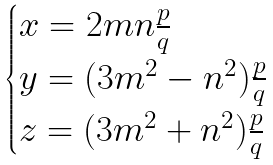<formula> <loc_0><loc_0><loc_500><loc_500>\begin{cases} x = 2 m n \frac { p } { q } \\ y = ( 3 m ^ { 2 } - n ^ { 2 } ) \frac { p } { q } \\ z = ( 3 m ^ { 2 } + n ^ { 2 } ) \frac { p } { q } \end{cases}</formula> 